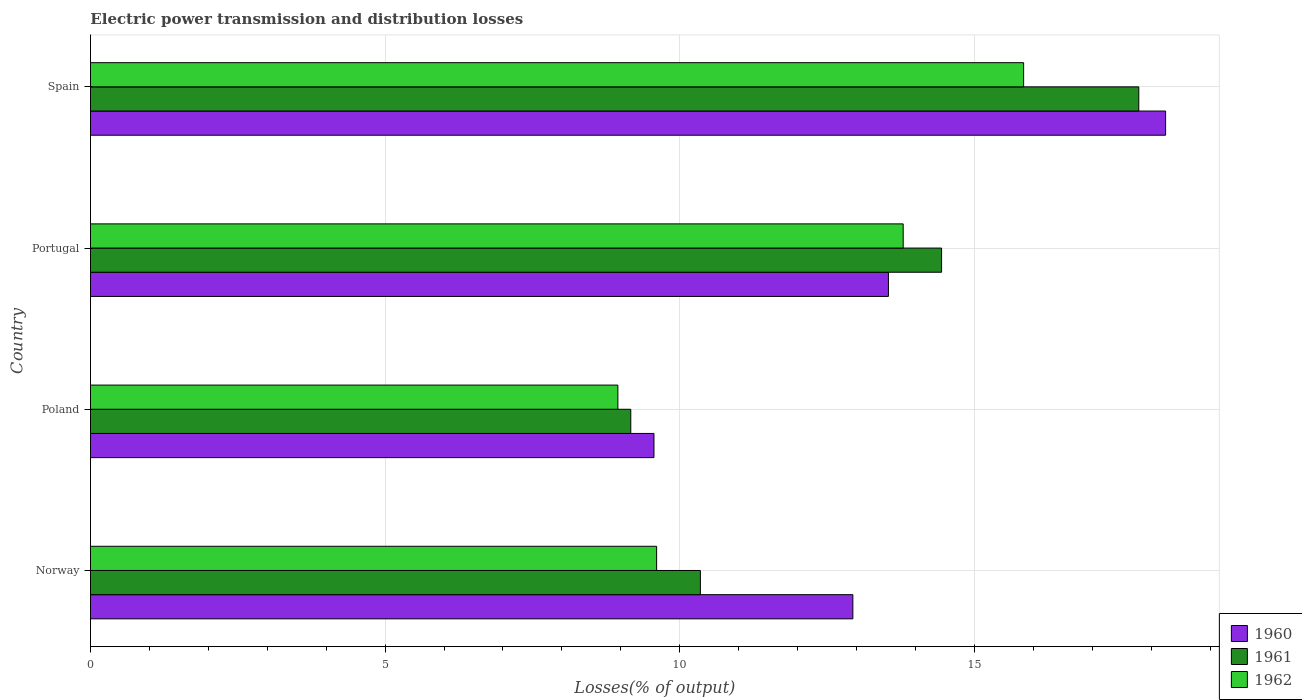How many groups of bars are there?
Give a very brief answer. 4. Are the number of bars per tick equal to the number of legend labels?
Your response must be concise. Yes. How many bars are there on the 1st tick from the top?
Your answer should be compact. 3. In how many cases, is the number of bars for a given country not equal to the number of legend labels?
Provide a short and direct response. 0. What is the electric power transmission and distribution losses in 1962 in Portugal?
Keep it short and to the point. 13.79. Across all countries, what is the maximum electric power transmission and distribution losses in 1960?
Ensure brevity in your answer.  18.24. Across all countries, what is the minimum electric power transmission and distribution losses in 1960?
Your answer should be very brief. 9.56. What is the total electric power transmission and distribution losses in 1961 in the graph?
Your response must be concise. 51.75. What is the difference between the electric power transmission and distribution losses in 1960 in Poland and that in Spain?
Offer a terse response. -8.68. What is the difference between the electric power transmission and distribution losses in 1960 in Poland and the electric power transmission and distribution losses in 1962 in Norway?
Your answer should be compact. -0.05. What is the average electric power transmission and distribution losses in 1961 per country?
Provide a short and direct response. 12.94. What is the difference between the electric power transmission and distribution losses in 1961 and electric power transmission and distribution losses in 1962 in Poland?
Give a very brief answer. 0.22. In how many countries, is the electric power transmission and distribution losses in 1961 greater than 1 %?
Keep it short and to the point. 4. What is the ratio of the electric power transmission and distribution losses in 1960 in Portugal to that in Spain?
Ensure brevity in your answer.  0.74. Is the electric power transmission and distribution losses in 1962 in Norway less than that in Spain?
Ensure brevity in your answer.  Yes. Is the difference between the electric power transmission and distribution losses in 1961 in Portugal and Spain greater than the difference between the electric power transmission and distribution losses in 1962 in Portugal and Spain?
Offer a very short reply. No. What is the difference between the highest and the second highest electric power transmission and distribution losses in 1961?
Give a very brief answer. 3.35. What is the difference between the highest and the lowest electric power transmission and distribution losses in 1961?
Provide a succinct answer. 8.62. What does the 2nd bar from the top in Norway represents?
Offer a very short reply. 1961. Is it the case that in every country, the sum of the electric power transmission and distribution losses in 1961 and electric power transmission and distribution losses in 1962 is greater than the electric power transmission and distribution losses in 1960?
Provide a short and direct response. Yes. Are all the bars in the graph horizontal?
Ensure brevity in your answer.  Yes. How many countries are there in the graph?
Give a very brief answer. 4. Does the graph contain any zero values?
Your answer should be very brief. No. Does the graph contain grids?
Your response must be concise. Yes. How are the legend labels stacked?
Offer a terse response. Vertical. What is the title of the graph?
Give a very brief answer. Electric power transmission and distribution losses. Does "2005" appear as one of the legend labels in the graph?
Keep it short and to the point. No. What is the label or title of the X-axis?
Provide a short and direct response. Losses(% of output). What is the label or title of the Y-axis?
Your answer should be compact. Country. What is the Losses(% of output) in 1960 in Norway?
Your answer should be very brief. 12.94. What is the Losses(% of output) of 1961 in Norway?
Your answer should be compact. 10.35. What is the Losses(% of output) in 1962 in Norway?
Make the answer very short. 9.61. What is the Losses(% of output) of 1960 in Poland?
Keep it short and to the point. 9.56. What is the Losses(% of output) of 1961 in Poland?
Your response must be concise. 9.17. What is the Losses(% of output) of 1962 in Poland?
Keep it short and to the point. 8.95. What is the Losses(% of output) of 1960 in Portugal?
Keep it short and to the point. 13.54. What is the Losses(% of output) in 1961 in Portugal?
Your answer should be compact. 14.44. What is the Losses(% of output) in 1962 in Portugal?
Your response must be concise. 13.79. What is the Losses(% of output) in 1960 in Spain?
Your answer should be compact. 18.24. What is the Losses(% of output) of 1961 in Spain?
Your response must be concise. 17.79. What is the Losses(% of output) in 1962 in Spain?
Provide a succinct answer. 15.83. Across all countries, what is the maximum Losses(% of output) of 1960?
Offer a very short reply. 18.24. Across all countries, what is the maximum Losses(% of output) of 1961?
Keep it short and to the point. 17.79. Across all countries, what is the maximum Losses(% of output) of 1962?
Provide a short and direct response. 15.83. Across all countries, what is the minimum Losses(% of output) of 1960?
Your response must be concise. 9.56. Across all countries, what is the minimum Losses(% of output) in 1961?
Give a very brief answer. 9.17. Across all countries, what is the minimum Losses(% of output) of 1962?
Keep it short and to the point. 8.95. What is the total Losses(% of output) of 1960 in the graph?
Ensure brevity in your answer.  54.28. What is the total Losses(% of output) of 1961 in the graph?
Offer a terse response. 51.75. What is the total Losses(% of output) of 1962 in the graph?
Make the answer very short. 48.18. What is the difference between the Losses(% of output) in 1960 in Norway and that in Poland?
Provide a succinct answer. 3.38. What is the difference between the Losses(% of output) of 1961 in Norway and that in Poland?
Give a very brief answer. 1.18. What is the difference between the Losses(% of output) in 1962 in Norway and that in Poland?
Make the answer very short. 0.66. What is the difference between the Losses(% of output) of 1960 in Norway and that in Portugal?
Your answer should be very brief. -0.6. What is the difference between the Losses(% of output) in 1961 in Norway and that in Portugal?
Provide a short and direct response. -4.09. What is the difference between the Losses(% of output) of 1962 in Norway and that in Portugal?
Your response must be concise. -4.18. What is the difference between the Losses(% of output) of 1960 in Norway and that in Spain?
Offer a terse response. -5.31. What is the difference between the Losses(% of output) in 1961 in Norway and that in Spain?
Your answer should be very brief. -7.44. What is the difference between the Losses(% of output) of 1962 in Norway and that in Spain?
Make the answer very short. -6.23. What is the difference between the Losses(% of output) in 1960 in Poland and that in Portugal?
Your response must be concise. -3.98. What is the difference between the Losses(% of output) in 1961 in Poland and that in Portugal?
Offer a terse response. -5.27. What is the difference between the Losses(% of output) of 1962 in Poland and that in Portugal?
Make the answer very short. -4.84. What is the difference between the Losses(% of output) in 1960 in Poland and that in Spain?
Offer a terse response. -8.68. What is the difference between the Losses(% of output) of 1961 in Poland and that in Spain?
Your answer should be compact. -8.62. What is the difference between the Losses(% of output) of 1962 in Poland and that in Spain?
Provide a short and direct response. -6.89. What is the difference between the Losses(% of output) in 1960 in Portugal and that in Spain?
Your response must be concise. -4.7. What is the difference between the Losses(% of output) of 1961 in Portugal and that in Spain?
Make the answer very short. -3.35. What is the difference between the Losses(% of output) of 1962 in Portugal and that in Spain?
Your answer should be compact. -2.04. What is the difference between the Losses(% of output) of 1960 in Norway and the Losses(% of output) of 1961 in Poland?
Your answer should be compact. 3.77. What is the difference between the Losses(% of output) in 1960 in Norway and the Losses(% of output) in 1962 in Poland?
Make the answer very short. 3.99. What is the difference between the Losses(% of output) of 1961 in Norway and the Losses(% of output) of 1962 in Poland?
Provide a succinct answer. 1.4. What is the difference between the Losses(% of output) in 1960 in Norway and the Losses(% of output) in 1961 in Portugal?
Ensure brevity in your answer.  -1.51. What is the difference between the Losses(% of output) in 1960 in Norway and the Losses(% of output) in 1962 in Portugal?
Your answer should be compact. -0.85. What is the difference between the Losses(% of output) of 1961 in Norway and the Losses(% of output) of 1962 in Portugal?
Your answer should be very brief. -3.44. What is the difference between the Losses(% of output) of 1960 in Norway and the Losses(% of output) of 1961 in Spain?
Keep it short and to the point. -4.85. What is the difference between the Losses(% of output) in 1960 in Norway and the Losses(% of output) in 1962 in Spain?
Your response must be concise. -2.9. What is the difference between the Losses(% of output) in 1961 in Norway and the Losses(% of output) in 1962 in Spain?
Offer a very short reply. -5.49. What is the difference between the Losses(% of output) in 1960 in Poland and the Losses(% of output) in 1961 in Portugal?
Offer a very short reply. -4.88. What is the difference between the Losses(% of output) of 1960 in Poland and the Losses(% of output) of 1962 in Portugal?
Make the answer very short. -4.23. What is the difference between the Losses(% of output) in 1961 in Poland and the Losses(% of output) in 1962 in Portugal?
Provide a succinct answer. -4.62. What is the difference between the Losses(% of output) of 1960 in Poland and the Losses(% of output) of 1961 in Spain?
Provide a short and direct response. -8.23. What is the difference between the Losses(% of output) of 1960 in Poland and the Losses(% of output) of 1962 in Spain?
Make the answer very short. -6.27. What is the difference between the Losses(% of output) of 1961 in Poland and the Losses(% of output) of 1962 in Spain?
Keep it short and to the point. -6.67. What is the difference between the Losses(% of output) of 1960 in Portugal and the Losses(% of output) of 1961 in Spain?
Ensure brevity in your answer.  -4.25. What is the difference between the Losses(% of output) of 1960 in Portugal and the Losses(% of output) of 1962 in Spain?
Ensure brevity in your answer.  -2.29. What is the difference between the Losses(% of output) in 1961 in Portugal and the Losses(% of output) in 1962 in Spain?
Offer a very short reply. -1.39. What is the average Losses(% of output) of 1960 per country?
Give a very brief answer. 13.57. What is the average Losses(% of output) of 1961 per country?
Offer a terse response. 12.94. What is the average Losses(% of output) in 1962 per country?
Provide a short and direct response. 12.05. What is the difference between the Losses(% of output) of 1960 and Losses(% of output) of 1961 in Norway?
Offer a very short reply. 2.59. What is the difference between the Losses(% of output) of 1960 and Losses(% of output) of 1962 in Norway?
Provide a succinct answer. 3.33. What is the difference between the Losses(% of output) in 1961 and Losses(% of output) in 1962 in Norway?
Make the answer very short. 0.74. What is the difference between the Losses(% of output) in 1960 and Losses(% of output) in 1961 in Poland?
Provide a succinct answer. 0.39. What is the difference between the Losses(% of output) of 1960 and Losses(% of output) of 1962 in Poland?
Your answer should be compact. 0.61. What is the difference between the Losses(% of output) in 1961 and Losses(% of output) in 1962 in Poland?
Provide a succinct answer. 0.22. What is the difference between the Losses(% of output) in 1960 and Losses(% of output) in 1961 in Portugal?
Give a very brief answer. -0.9. What is the difference between the Losses(% of output) of 1960 and Losses(% of output) of 1962 in Portugal?
Your answer should be very brief. -0.25. What is the difference between the Losses(% of output) of 1961 and Losses(% of output) of 1962 in Portugal?
Your answer should be very brief. 0.65. What is the difference between the Losses(% of output) of 1960 and Losses(% of output) of 1961 in Spain?
Offer a terse response. 0.46. What is the difference between the Losses(% of output) of 1960 and Losses(% of output) of 1962 in Spain?
Your response must be concise. 2.41. What is the difference between the Losses(% of output) of 1961 and Losses(% of output) of 1962 in Spain?
Offer a terse response. 1.95. What is the ratio of the Losses(% of output) in 1960 in Norway to that in Poland?
Your answer should be compact. 1.35. What is the ratio of the Losses(% of output) in 1961 in Norway to that in Poland?
Your answer should be very brief. 1.13. What is the ratio of the Losses(% of output) in 1962 in Norway to that in Poland?
Make the answer very short. 1.07. What is the ratio of the Losses(% of output) in 1960 in Norway to that in Portugal?
Ensure brevity in your answer.  0.96. What is the ratio of the Losses(% of output) in 1961 in Norway to that in Portugal?
Keep it short and to the point. 0.72. What is the ratio of the Losses(% of output) of 1962 in Norway to that in Portugal?
Provide a short and direct response. 0.7. What is the ratio of the Losses(% of output) of 1960 in Norway to that in Spain?
Give a very brief answer. 0.71. What is the ratio of the Losses(% of output) of 1961 in Norway to that in Spain?
Your answer should be very brief. 0.58. What is the ratio of the Losses(% of output) in 1962 in Norway to that in Spain?
Keep it short and to the point. 0.61. What is the ratio of the Losses(% of output) of 1960 in Poland to that in Portugal?
Your answer should be very brief. 0.71. What is the ratio of the Losses(% of output) of 1961 in Poland to that in Portugal?
Ensure brevity in your answer.  0.63. What is the ratio of the Losses(% of output) in 1962 in Poland to that in Portugal?
Keep it short and to the point. 0.65. What is the ratio of the Losses(% of output) in 1960 in Poland to that in Spain?
Offer a terse response. 0.52. What is the ratio of the Losses(% of output) of 1961 in Poland to that in Spain?
Ensure brevity in your answer.  0.52. What is the ratio of the Losses(% of output) of 1962 in Poland to that in Spain?
Make the answer very short. 0.57. What is the ratio of the Losses(% of output) in 1960 in Portugal to that in Spain?
Offer a very short reply. 0.74. What is the ratio of the Losses(% of output) of 1961 in Portugal to that in Spain?
Your answer should be compact. 0.81. What is the ratio of the Losses(% of output) in 1962 in Portugal to that in Spain?
Your answer should be very brief. 0.87. What is the difference between the highest and the second highest Losses(% of output) of 1960?
Your response must be concise. 4.7. What is the difference between the highest and the second highest Losses(% of output) in 1961?
Ensure brevity in your answer.  3.35. What is the difference between the highest and the second highest Losses(% of output) of 1962?
Your answer should be compact. 2.04. What is the difference between the highest and the lowest Losses(% of output) in 1960?
Make the answer very short. 8.68. What is the difference between the highest and the lowest Losses(% of output) of 1961?
Ensure brevity in your answer.  8.62. What is the difference between the highest and the lowest Losses(% of output) of 1962?
Keep it short and to the point. 6.89. 